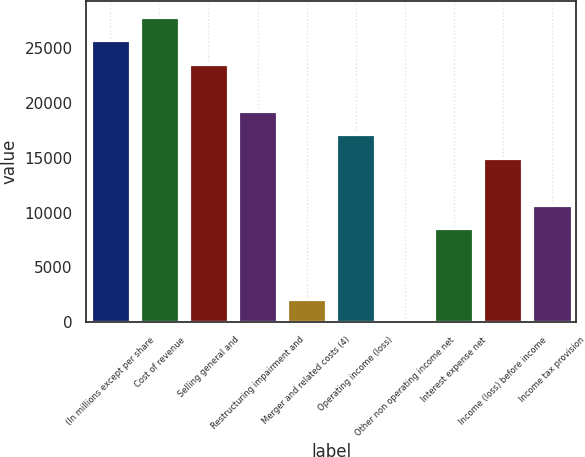Convert chart. <chart><loc_0><loc_0><loc_500><loc_500><bar_chart><fcel>(In millions except per share<fcel>Cost of revenue<fcel>Selling general and<fcel>Restructuring impairment and<fcel>Merger and related costs (4)<fcel>Operating income (loss)<fcel>Other non operating income net<fcel>Interest expense net<fcel>Income (loss) before income<fcel>Income tax provision<nl><fcel>25758.6<fcel>27904.9<fcel>23612.3<fcel>19319.7<fcel>2149.3<fcel>17173.4<fcel>3<fcel>8588.2<fcel>15027.1<fcel>10734.5<nl></chart> 